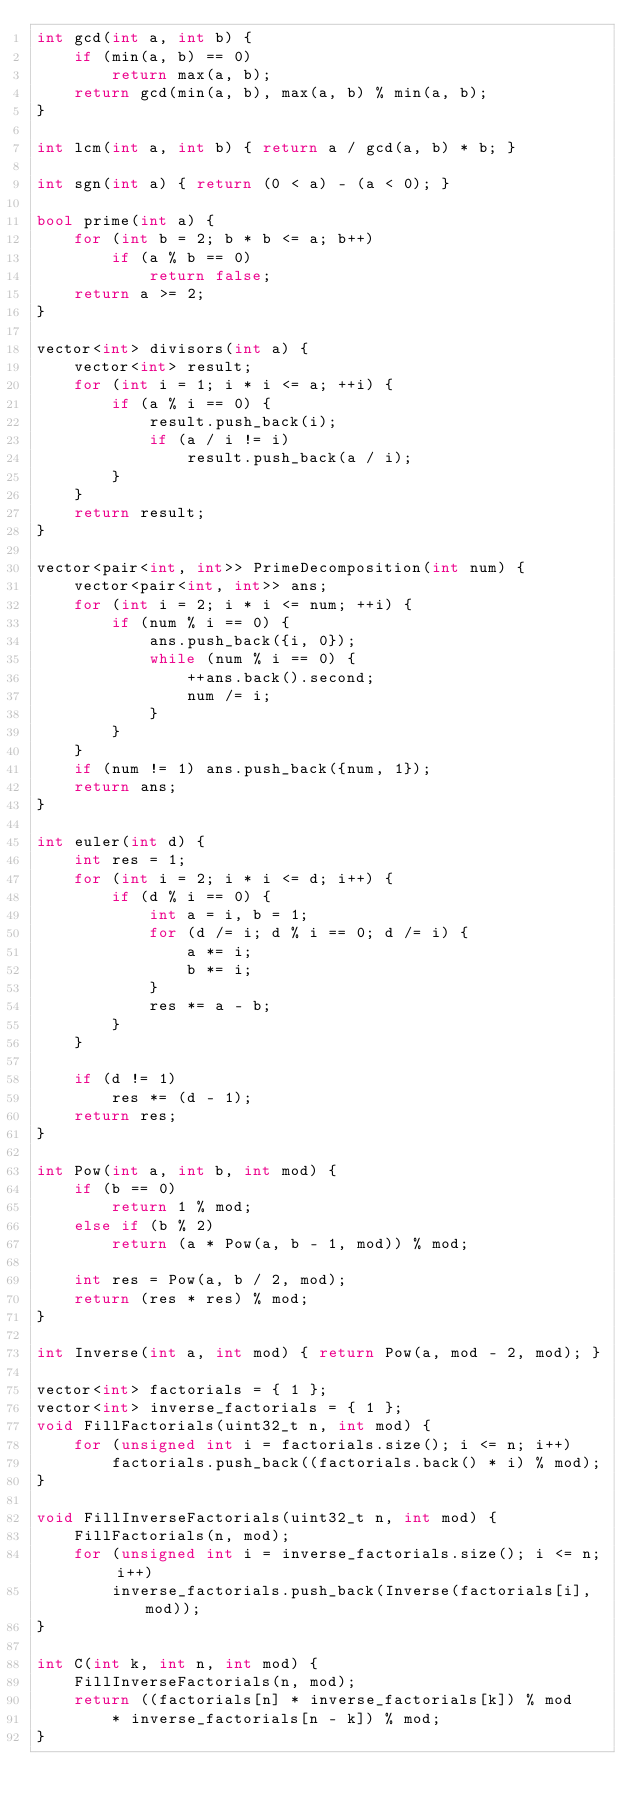Convert code to text. <code><loc_0><loc_0><loc_500><loc_500><_C++_>int gcd(int a, int b) {
    if (min(a, b) == 0)
        return max(a, b);
    return gcd(min(a, b), max(a, b) % min(a, b);
}

int lcm(int a, int b) { return a / gcd(a, b) * b; }

int sgn(int a) { return (0 < a) - (a < 0); }

bool prime(int a) {
    for (int b = 2; b * b <= a; b++)
        if (a % b == 0)
            return false;
    return a >= 2;
}

vector<int> divisors(int a) {
    vector<int> result;
    for (int i = 1; i * i <= a; ++i) {
        if (a % i == 0) {
            result.push_back(i);
            if (a / i != i)
                result.push_back(a / i);
        }
    }
    return result;
}

vector<pair<int, int>> PrimeDecomposition(int num) {
    vector<pair<int, int>> ans;
    for (int i = 2; i * i <= num; ++i) {
        if (num % i == 0) {
            ans.push_back({i, 0});
            while (num % i == 0) {
                ++ans.back().second;
                num /= i;
            }
        }
    }
    if (num != 1) ans.push_back({num, 1});
    return ans;
}

int euler(int d) {
    int res = 1;
    for (int i = 2; i * i <= d; i++) {
        if (d % i == 0) {
            int a = i, b = 1; 
            for (d /= i; d % i == 0; d /= i) {
                a *= i;
                b *= i;
            }
            res *= a - b;
        }
    }
    
    if (d != 1)
        res *= (d - 1);
    return res;
}

int Pow(int a, int b, int mod) {
    if (b == 0)
        return 1 % mod;
    else if (b % 2)
        return (a * Pow(a, b - 1, mod)) % mod;

    int res = Pow(a, b / 2, mod);
    return (res * res) % mod;
}

int Inverse(int a, int mod) { return Pow(a, mod - 2, mod); }

vector<int> factorials = { 1 };
vector<int> inverse_factorials = { 1 };
void FillFactorials(uint32_t n, int mod) {
    for (unsigned int i = factorials.size(); i <= n; i++)
        factorials.push_back((factorials.back() * i) % mod);
}

void FillInverseFactorials(uint32_t n, int mod) {
    FillFactorials(n, mod);
    for (unsigned int i = inverse_factorials.size(); i <= n; i++)
        inverse_factorials.push_back(Inverse(factorials[i], mod));
}

int C(int k, int n, int mod) {
    FillInverseFactorials(n, mod);
    return ((factorials[n] * inverse_factorials[k]) % mod 
        * inverse_factorials[n - k]) % mod;
}
</code> 